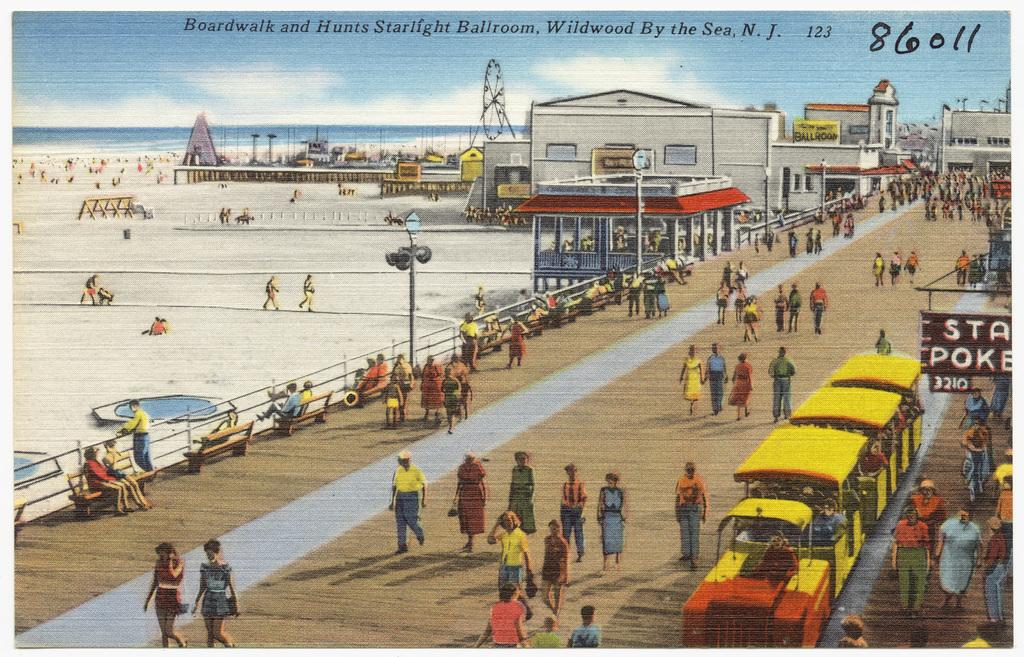<image>
Relay a brief, clear account of the picture shown. Boardwalk and Hunts starlight Ballroom by the sea N.J. 